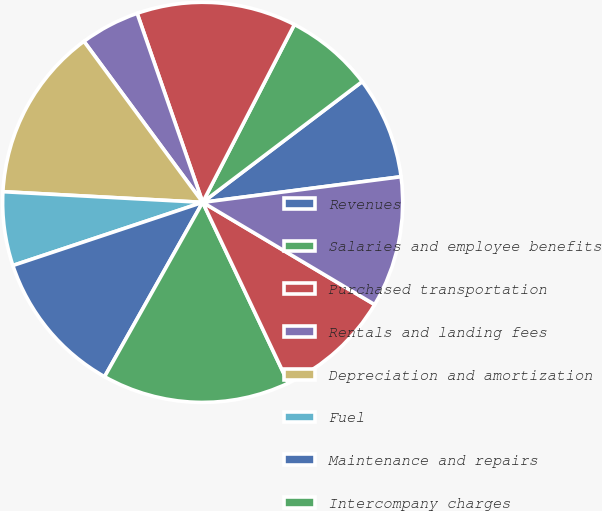Convert chart. <chart><loc_0><loc_0><loc_500><loc_500><pie_chart><fcel>Revenues<fcel>Salaries and employee benefits<fcel>Purchased transportation<fcel>Rentals and landing fees<fcel>Depreciation and amortization<fcel>Fuel<fcel>Maintenance and repairs<fcel>Intercompany charges<fcel>Other<fcel>Total operating expenses<nl><fcel>8.27%<fcel>7.11%<fcel>12.89%<fcel>4.8%<fcel>14.04%<fcel>5.96%<fcel>11.73%<fcel>15.2%<fcel>9.42%<fcel>10.58%<nl></chart> 